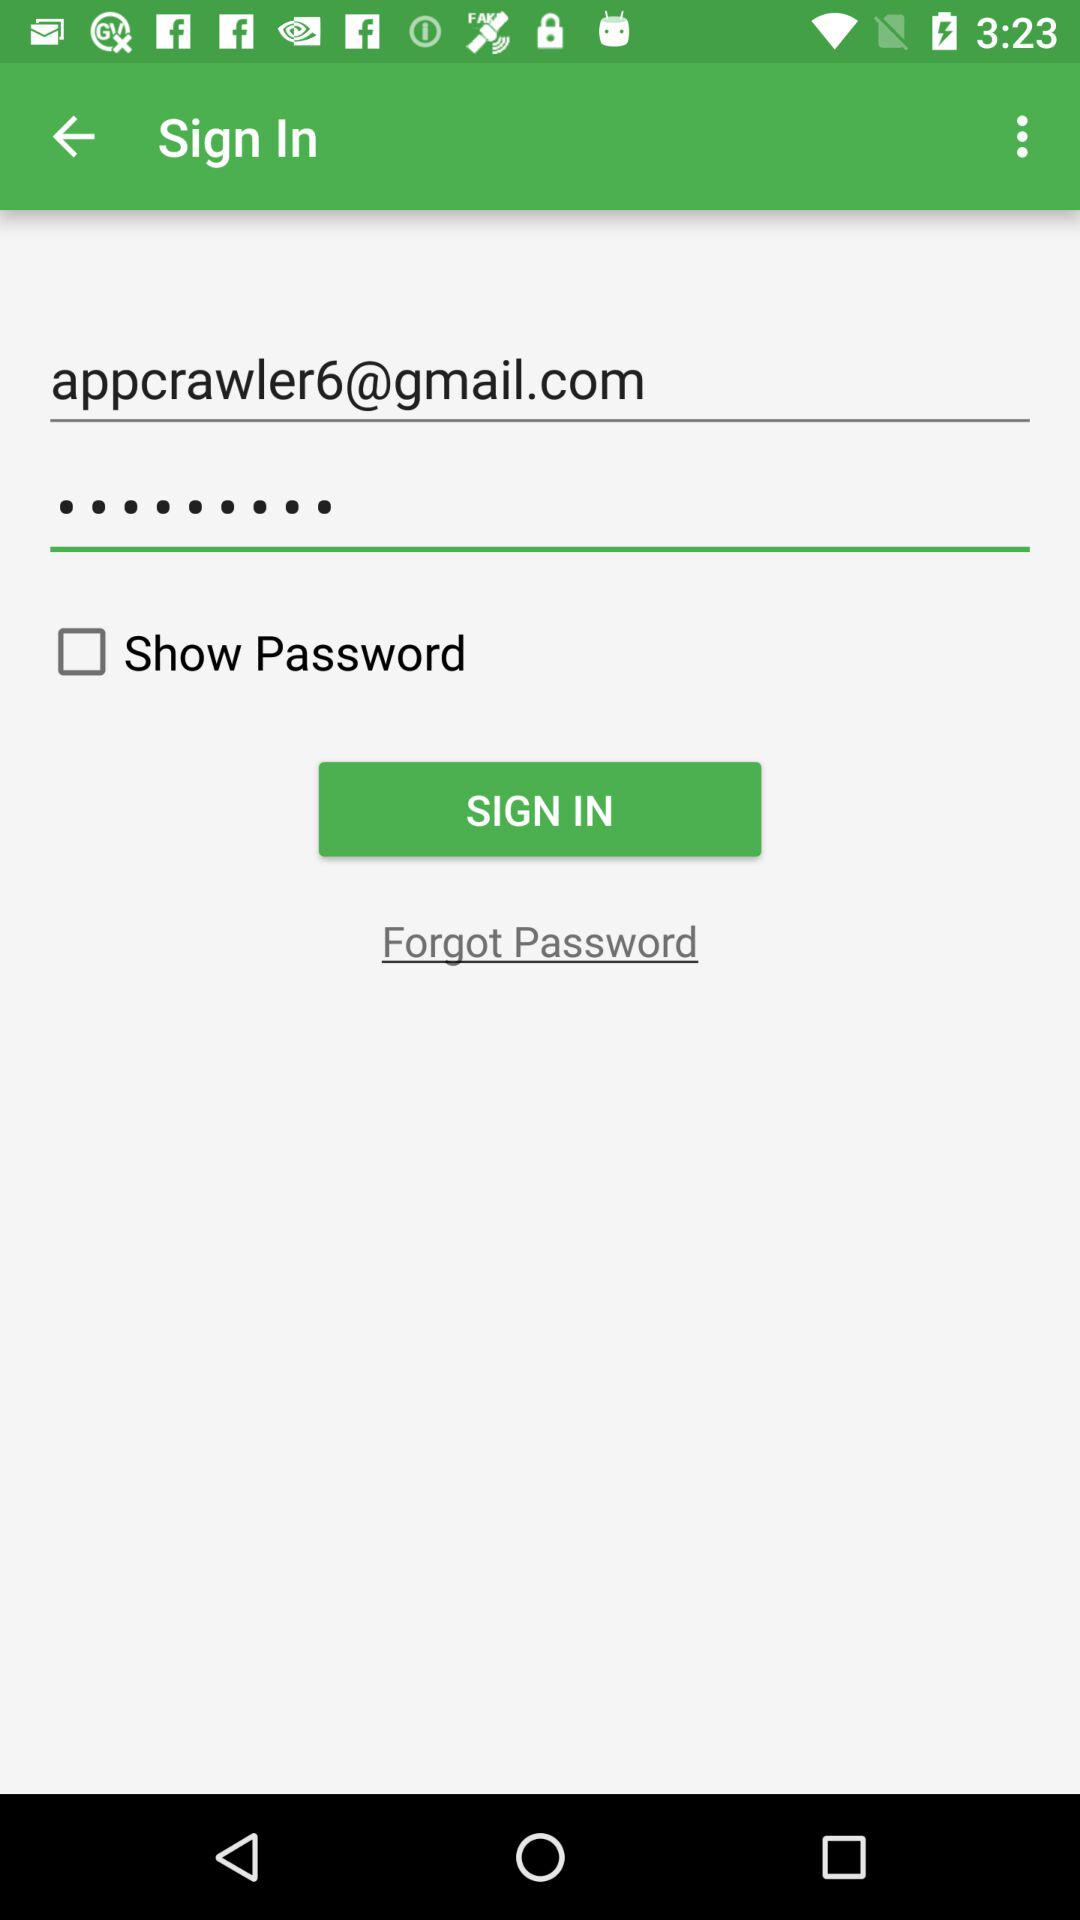What is a Gmail account? The Gmail account is appcrawler6@gmail.com. 